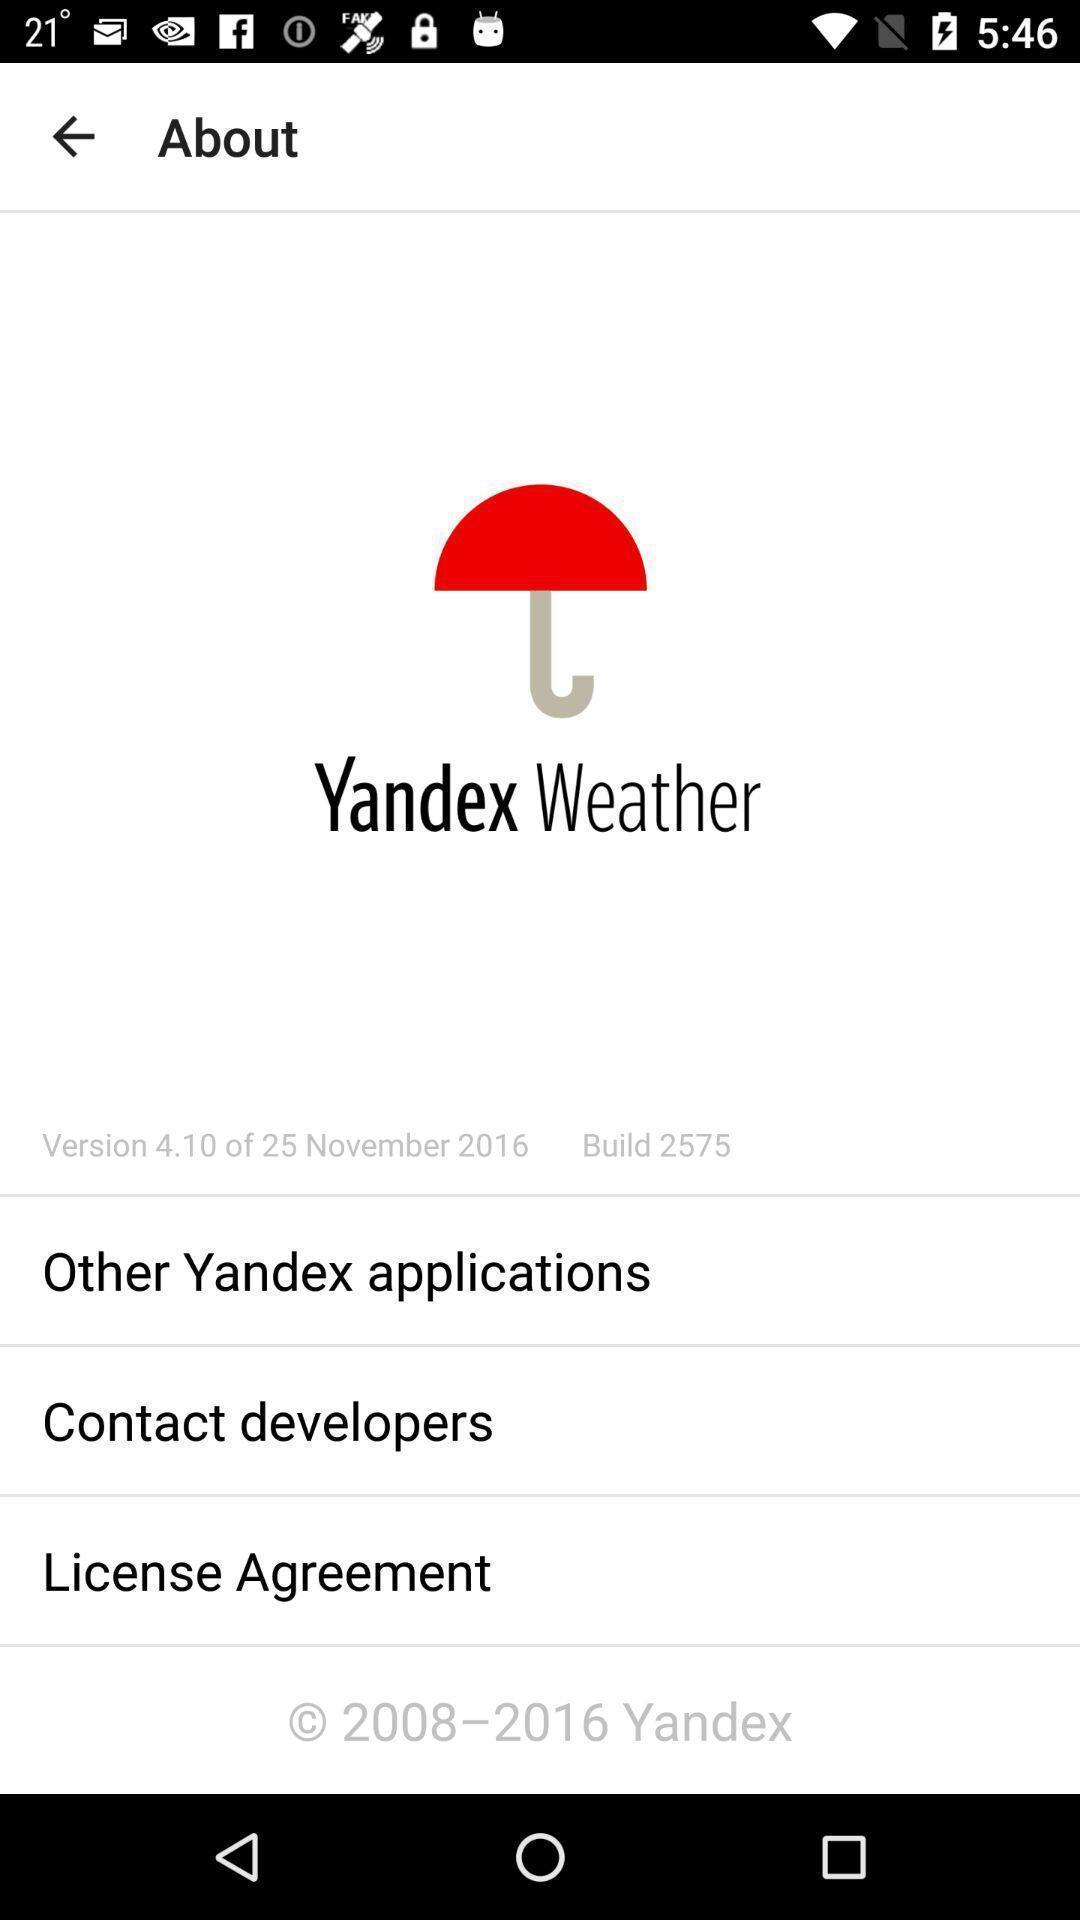What is the overall content of this screenshot? Page displaying various options in weather application. 